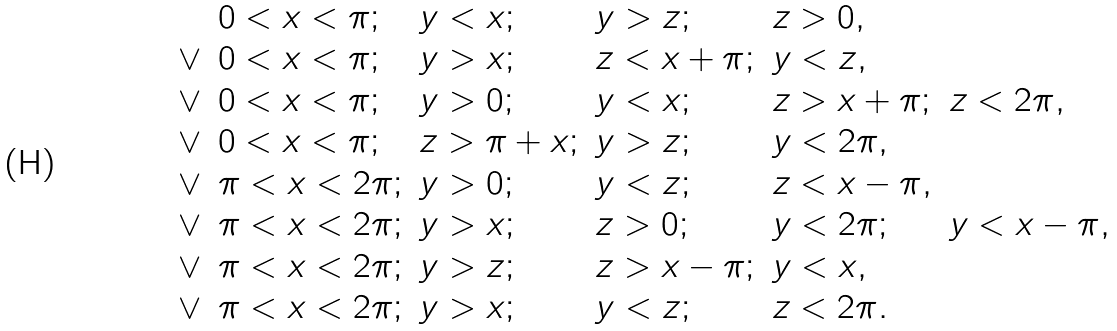Convert formula to latex. <formula><loc_0><loc_0><loc_500><loc_500>\begin{array} { l l l l l l } & 0 < x < \pi ; & y < x ; & y > z ; & z > 0 , \\ \vee & 0 < x < \pi ; & y > x ; & z < x + \pi ; & y < z , \\ \vee & 0 < x < \pi ; & y > 0 ; & y < x ; & z > x + \pi ; & z < 2 \pi , \\ \vee & 0 < x < \pi ; & z > \pi + x ; & y > z ; & y < 2 \pi , \\ \vee & \pi < x < 2 \pi ; & y > 0 ; & y < z ; & z < x - \pi , \\ \vee & \pi < x < 2 \pi ; & y > x ; & z > 0 ; & y < 2 \pi ; & y < x - \pi , \\ \vee & \pi < x < 2 \pi ; & y > z ; & z > x - \pi ; & y < x , \\ \vee & \pi < x < 2 \pi ; & y > x ; & y < z ; & z < 2 \pi . & \end{array}</formula> 